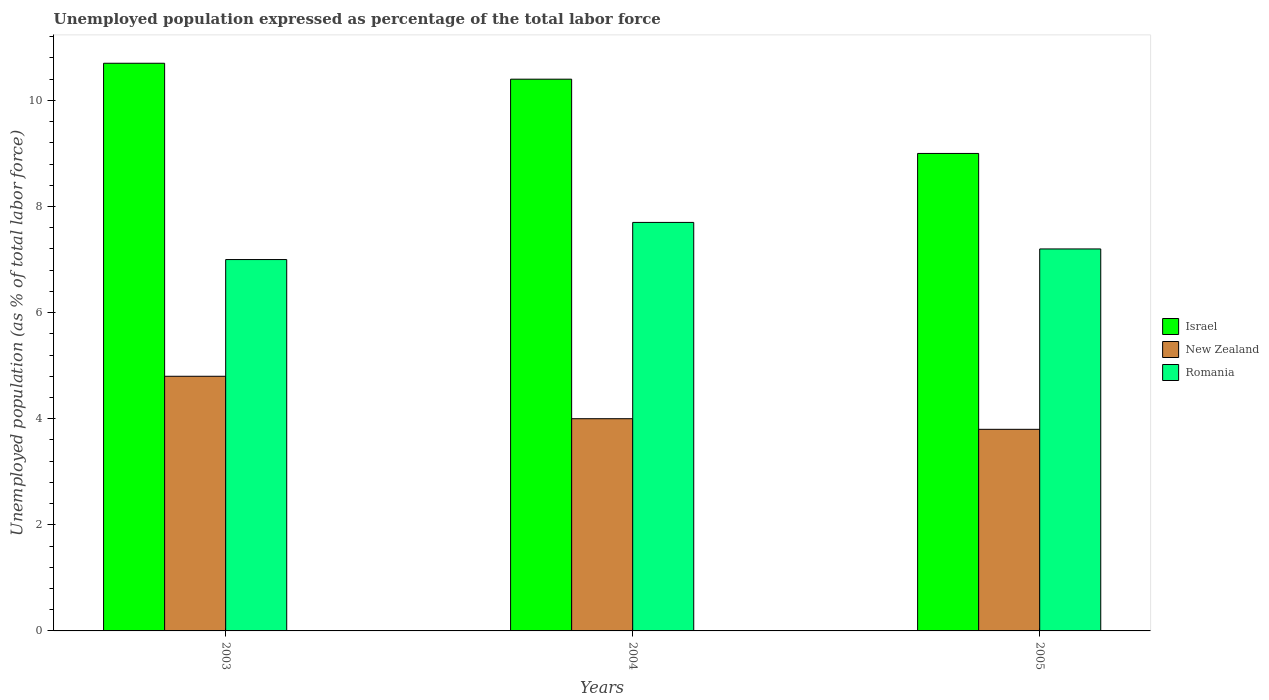How many different coloured bars are there?
Make the answer very short. 3. How many groups of bars are there?
Make the answer very short. 3. Are the number of bars per tick equal to the number of legend labels?
Ensure brevity in your answer.  Yes. Are the number of bars on each tick of the X-axis equal?
Keep it short and to the point. Yes. What is the label of the 1st group of bars from the left?
Keep it short and to the point. 2003. What is the unemployment in in Romania in 2005?
Provide a succinct answer. 7.2. Across all years, what is the maximum unemployment in in Israel?
Give a very brief answer. 10.7. In which year was the unemployment in in Israel maximum?
Ensure brevity in your answer.  2003. In which year was the unemployment in in New Zealand minimum?
Provide a succinct answer. 2005. What is the total unemployment in in Israel in the graph?
Offer a very short reply. 30.1. What is the difference between the unemployment in in Romania in 2004 and that in 2005?
Provide a succinct answer. 0.5. What is the average unemployment in in New Zealand per year?
Ensure brevity in your answer.  4.2. In the year 2004, what is the difference between the unemployment in in Romania and unemployment in in Israel?
Make the answer very short. -2.7. What is the ratio of the unemployment in in Romania in 2004 to that in 2005?
Give a very brief answer. 1.07. Is the unemployment in in New Zealand in 2003 less than that in 2005?
Give a very brief answer. No. Is the difference between the unemployment in in Romania in 2004 and 2005 greater than the difference between the unemployment in in Israel in 2004 and 2005?
Give a very brief answer. No. What is the difference between the highest and the second highest unemployment in in New Zealand?
Provide a succinct answer. 0.8. What is the difference between the highest and the lowest unemployment in in Romania?
Keep it short and to the point. 0.7. What does the 3rd bar from the left in 2003 represents?
Offer a terse response. Romania. What does the 3rd bar from the right in 2004 represents?
Offer a very short reply. Israel. Are all the bars in the graph horizontal?
Offer a very short reply. No. How many years are there in the graph?
Provide a short and direct response. 3. Are the values on the major ticks of Y-axis written in scientific E-notation?
Your answer should be compact. No. Does the graph contain grids?
Give a very brief answer. No. Where does the legend appear in the graph?
Offer a terse response. Center right. How many legend labels are there?
Offer a very short reply. 3. How are the legend labels stacked?
Offer a very short reply. Vertical. What is the title of the graph?
Give a very brief answer. Unemployed population expressed as percentage of the total labor force. What is the label or title of the X-axis?
Your answer should be very brief. Years. What is the label or title of the Y-axis?
Offer a terse response. Unemployed population (as % of total labor force). What is the Unemployed population (as % of total labor force) of Israel in 2003?
Provide a short and direct response. 10.7. What is the Unemployed population (as % of total labor force) in New Zealand in 2003?
Provide a short and direct response. 4.8. What is the Unemployed population (as % of total labor force) of Romania in 2003?
Ensure brevity in your answer.  7. What is the Unemployed population (as % of total labor force) of Israel in 2004?
Provide a short and direct response. 10.4. What is the Unemployed population (as % of total labor force) of New Zealand in 2004?
Provide a short and direct response. 4. What is the Unemployed population (as % of total labor force) of Romania in 2004?
Give a very brief answer. 7.7. What is the Unemployed population (as % of total labor force) of Israel in 2005?
Your answer should be very brief. 9. What is the Unemployed population (as % of total labor force) of New Zealand in 2005?
Your answer should be compact. 3.8. What is the Unemployed population (as % of total labor force) of Romania in 2005?
Ensure brevity in your answer.  7.2. Across all years, what is the maximum Unemployed population (as % of total labor force) of Israel?
Give a very brief answer. 10.7. Across all years, what is the maximum Unemployed population (as % of total labor force) of New Zealand?
Give a very brief answer. 4.8. Across all years, what is the maximum Unemployed population (as % of total labor force) of Romania?
Your response must be concise. 7.7. Across all years, what is the minimum Unemployed population (as % of total labor force) of New Zealand?
Make the answer very short. 3.8. Across all years, what is the minimum Unemployed population (as % of total labor force) of Romania?
Make the answer very short. 7. What is the total Unemployed population (as % of total labor force) of Israel in the graph?
Your response must be concise. 30.1. What is the total Unemployed population (as % of total labor force) in Romania in the graph?
Your answer should be very brief. 21.9. What is the difference between the Unemployed population (as % of total labor force) of Israel in 2003 and that in 2004?
Give a very brief answer. 0.3. What is the difference between the Unemployed population (as % of total labor force) in New Zealand in 2003 and that in 2004?
Your answer should be very brief. 0.8. What is the difference between the Unemployed population (as % of total labor force) in Romania in 2003 and that in 2004?
Make the answer very short. -0.7. What is the difference between the Unemployed population (as % of total labor force) of Israel in 2003 and that in 2005?
Your response must be concise. 1.7. What is the difference between the Unemployed population (as % of total labor force) of Romania in 2003 and that in 2005?
Provide a succinct answer. -0.2. What is the difference between the Unemployed population (as % of total labor force) in New Zealand in 2004 and that in 2005?
Your response must be concise. 0.2. What is the difference between the Unemployed population (as % of total labor force) in Romania in 2004 and that in 2005?
Your answer should be compact. 0.5. What is the difference between the Unemployed population (as % of total labor force) of Israel in 2003 and the Unemployed population (as % of total labor force) of New Zealand in 2004?
Give a very brief answer. 6.7. What is the difference between the Unemployed population (as % of total labor force) of Israel in 2003 and the Unemployed population (as % of total labor force) of Romania in 2004?
Offer a terse response. 3. What is the difference between the Unemployed population (as % of total labor force) in Israel in 2003 and the Unemployed population (as % of total labor force) in Romania in 2005?
Offer a very short reply. 3.5. What is the difference between the Unemployed population (as % of total labor force) of Israel in 2004 and the Unemployed population (as % of total labor force) of New Zealand in 2005?
Make the answer very short. 6.6. What is the average Unemployed population (as % of total labor force) of Israel per year?
Offer a terse response. 10.03. In the year 2003, what is the difference between the Unemployed population (as % of total labor force) of Israel and Unemployed population (as % of total labor force) of Romania?
Provide a succinct answer. 3.7. In the year 2003, what is the difference between the Unemployed population (as % of total labor force) of New Zealand and Unemployed population (as % of total labor force) of Romania?
Provide a short and direct response. -2.2. In the year 2004, what is the difference between the Unemployed population (as % of total labor force) in Israel and Unemployed population (as % of total labor force) in Romania?
Offer a very short reply. 2.7. In the year 2004, what is the difference between the Unemployed population (as % of total labor force) in New Zealand and Unemployed population (as % of total labor force) in Romania?
Provide a succinct answer. -3.7. In the year 2005, what is the difference between the Unemployed population (as % of total labor force) of Israel and Unemployed population (as % of total labor force) of Romania?
Your response must be concise. 1.8. What is the ratio of the Unemployed population (as % of total labor force) in Israel in 2003 to that in 2004?
Your response must be concise. 1.03. What is the ratio of the Unemployed population (as % of total labor force) in New Zealand in 2003 to that in 2004?
Your response must be concise. 1.2. What is the ratio of the Unemployed population (as % of total labor force) of Israel in 2003 to that in 2005?
Ensure brevity in your answer.  1.19. What is the ratio of the Unemployed population (as % of total labor force) in New Zealand in 2003 to that in 2005?
Ensure brevity in your answer.  1.26. What is the ratio of the Unemployed population (as % of total labor force) in Romania in 2003 to that in 2005?
Offer a very short reply. 0.97. What is the ratio of the Unemployed population (as % of total labor force) in Israel in 2004 to that in 2005?
Offer a terse response. 1.16. What is the ratio of the Unemployed population (as % of total labor force) in New Zealand in 2004 to that in 2005?
Your answer should be compact. 1.05. What is the ratio of the Unemployed population (as % of total labor force) in Romania in 2004 to that in 2005?
Provide a short and direct response. 1.07. What is the difference between the highest and the second highest Unemployed population (as % of total labor force) of Romania?
Provide a succinct answer. 0.5. What is the difference between the highest and the lowest Unemployed population (as % of total labor force) in New Zealand?
Provide a succinct answer. 1. 